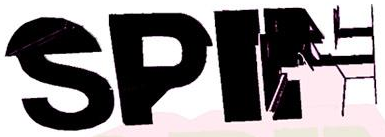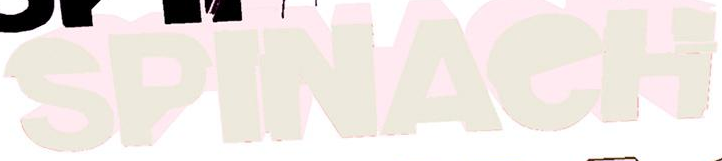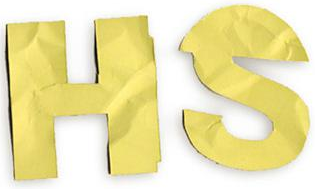What text appears in these images from left to right, separated by a semicolon? SPIN; SPINAeH; HS 